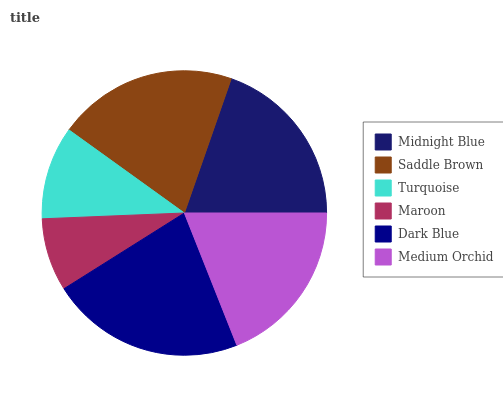Is Maroon the minimum?
Answer yes or no. Yes. Is Dark Blue the maximum?
Answer yes or no. Yes. Is Saddle Brown the minimum?
Answer yes or no. No. Is Saddle Brown the maximum?
Answer yes or no. No. Is Saddle Brown greater than Midnight Blue?
Answer yes or no. Yes. Is Midnight Blue less than Saddle Brown?
Answer yes or no. Yes. Is Midnight Blue greater than Saddle Brown?
Answer yes or no. No. Is Saddle Brown less than Midnight Blue?
Answer yes or no. No. Is Midnight Blue the high median?
Answer yes or no. Yes. Is Medium Orchid the low median?
Answer yes or no. Yes. Is Saddle Brown the high median?
Answer yes or no. No. Is Maroon the low median?
Answer yes or no. No. 